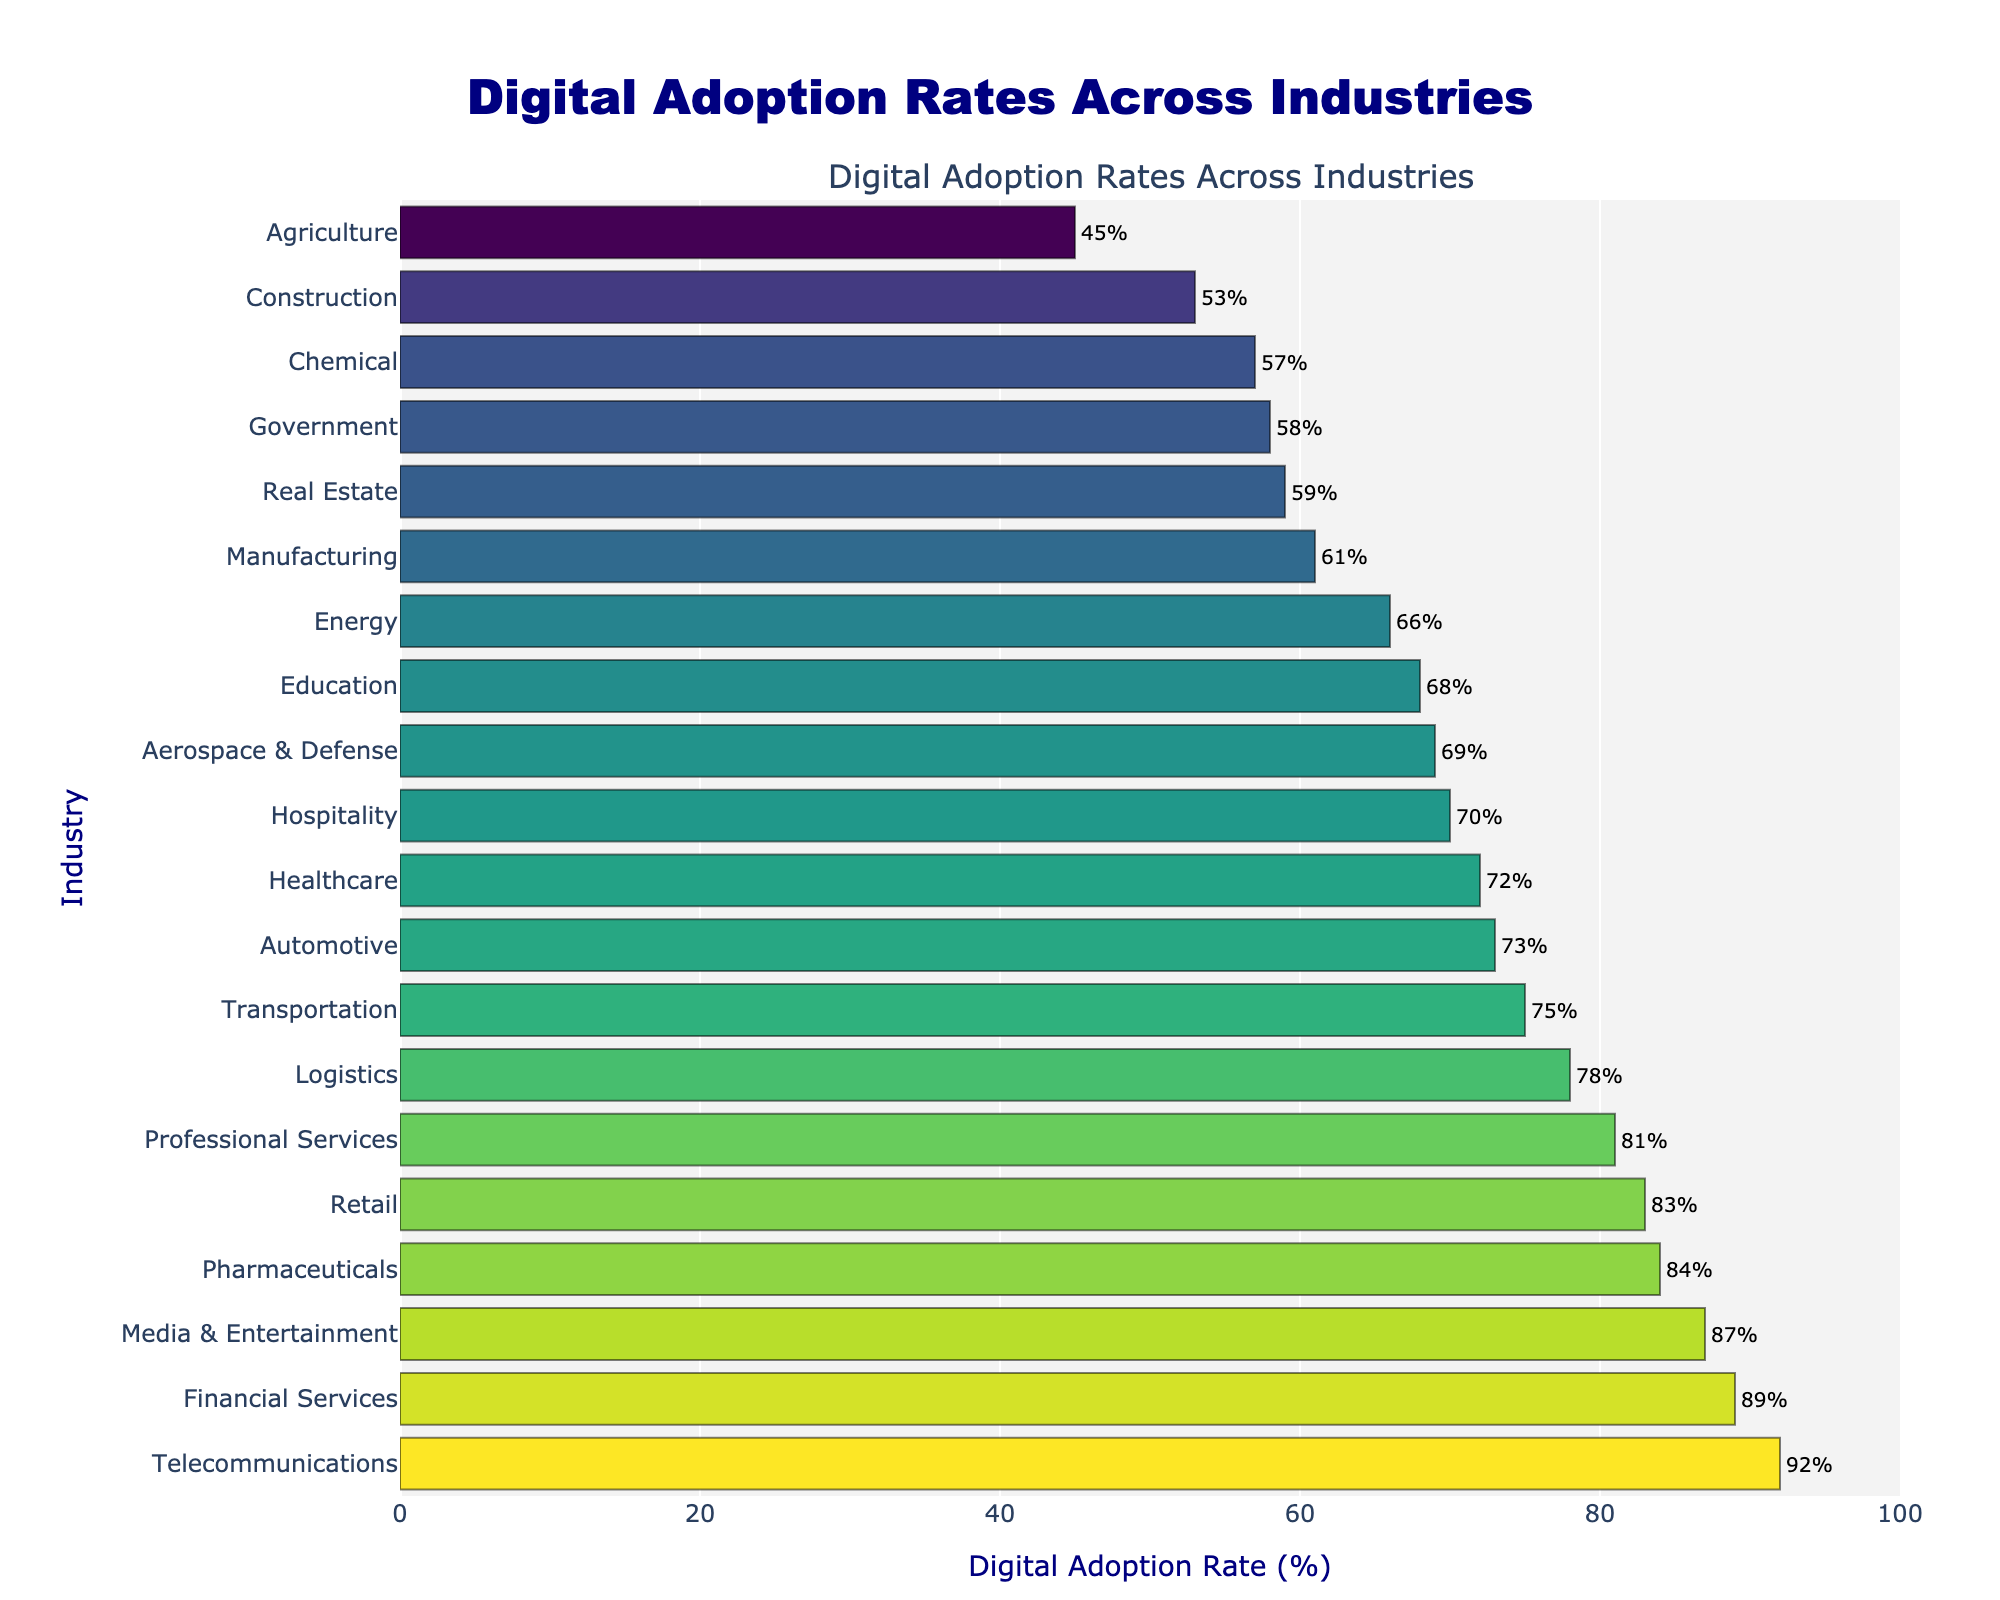Which industry has the highest digital adoption rate? The industry with the highest bar and the highest value shown is Telecommunications with a rate of 92%.
Answer: Telecommunications Which industry has the lowest digital adoption rate? The industry with the shortest bar and the lowest value shown is Agriculture with a rate of 45%.
Answer: Agriculture What is the difference in digital adoption rates between the Financial Services and Manufacturing industries? The digital adoption rate for Financial Services is 89%, and for Manufacturing, it is 61%. The difference is 89% - 61%.
Answer: 28% How many industries have a digital adoption rate higher than 80%? The industries that have bars reaching beyond 80% are Financial Services, Retail, Telecommunications, Media & Entertainment, Professional Services, Pharmaceuticals. Counting them gives us six industries.
Answer: 6 What is the average digital adoption rate of the Healthcare, Education, and Automotive industries? Summing up the rates for Healthcare (72%), Education (68%), and Automotive (73%) gives 213. Dividing by 3 gives the average.
Answer: 71% Which three industries have the closest digital adoption rates? The three industries with the closest bars are Healthcare (72%), Hospitality (70%), and Aerospace & Defense (69%), where the digital adoption rates are very close to each other.
Answer: Healthcare, Hospitality, Aerospace & Defense What’s the combined digital adoption rate of Agriculture, Construction, and Government industries? Adding the rates for Agriculture (45%), Construction (53%), and Government (58%) gives the sum 45 + 53 + 58 = 156.
Answer: 156% Which industry has a higher digital adoption rate, Media & Entertainment or Healthcare? Comparing the bars for Media & Entertainment (87%) and Healthcare (72%), Media & Entertainment has a higher rate.
Answer: Media & Entertainment Is the digital adoption rate of the Retail industry greater or less than the Aerospace & Defense industry? The bar for Retail stands at 83%, whereas Aerospace & Defense stands at 69%. Retail is greater.
Answer: Greater Determine the median digital adoption rate among the industries. Sorting the rates and finding the middle value provides the median. The sorted rates are: 45, 53, 57, 58, 59, 61, 66, 68, 69, 70, 72, 73, 75, 78, 81, 83, 84, 87, 89, 92. The middle values are 70 and 72, so their average is (70+72)/2.
Answer: 71% 